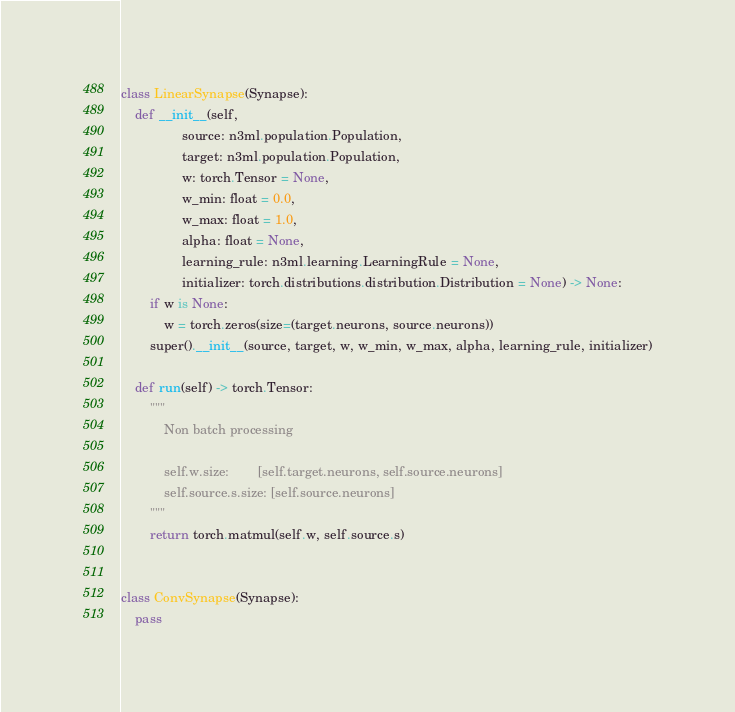<code> <loc_0><loc_0><loc_500><loc_500><_Python_>class LinearSynapse(Synapse):
    def __init__(self,
                 source: n3ml.population.Population,
                 target: n3ml.population.Population,
                 w: torch.Tensor = None,
                 w_min: float = 0.0,
                 w_max: float = 1.0,
                 alpha: float = None,
                 learning_rule: n3ml.learning.LearningRule = None,
                 initializer: torch.distributions.distribution.Distribution = None) -> None:
        if w is None:
            w = torch.zeros(size=(target.neurons, source.neurons))
        super().__init__(source, target, w, w_min, w_max, alpha, learning_rule, initializer)

    def run(self) -> torch.Tensor:
        """
            Non batch processing
        
            self.w.size:        [self.target.neurons, self.source.neurons]
            self.source.s.size: [self.source.neurons]
        """
        return torch.matmul(self.w, self.source.s)


class ConvSynapse(Synapse):
    pass
</code> 